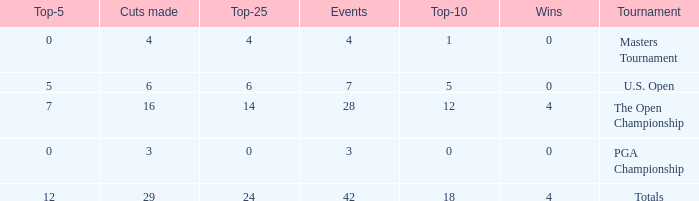What is the lowest for top-25 with events smaller than 42 in a U.S. Open with a top-10 smaller than 5? None. 